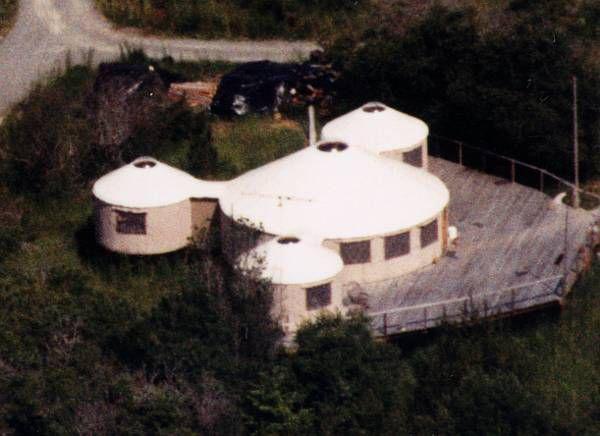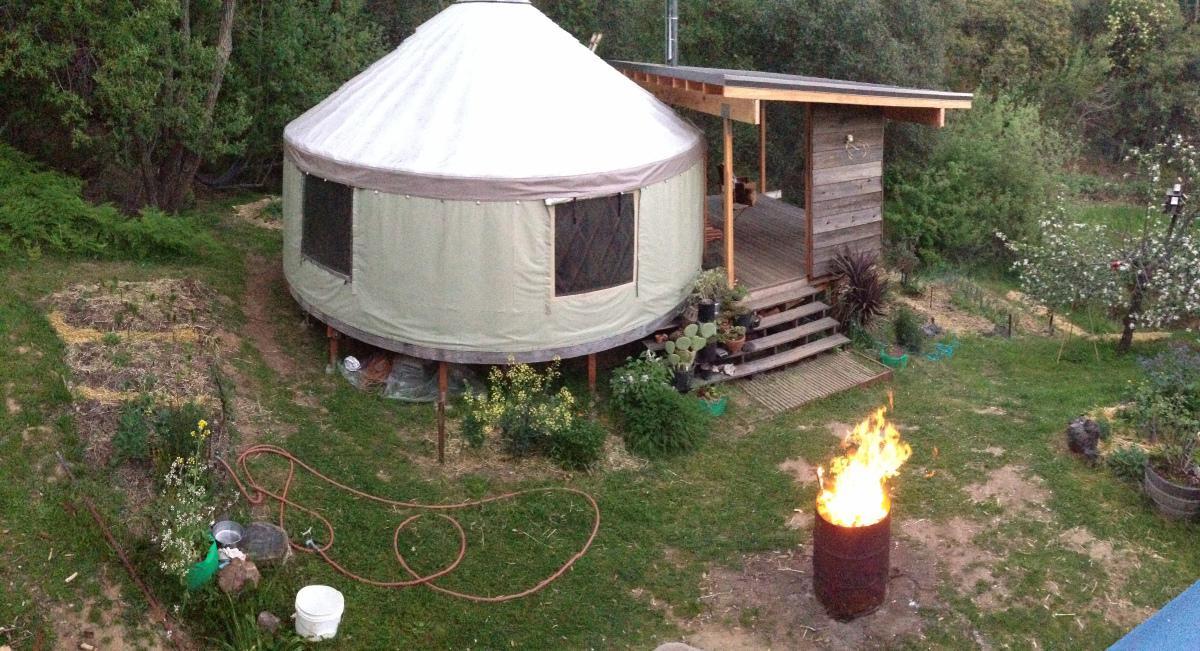The first image is the image on the left, the second image is the image on the right. Considering the images on both sides, is "One image contains two round structures wrapped in greenish-blue material and situated among trees." valid? Answer yes or no. No. The first image is the image on the left, the second image is the image on the right. Examine the images to the left and right. Is the description "There are two white huts near each other in the image on the right." accurate? Answer yes or no. No. 